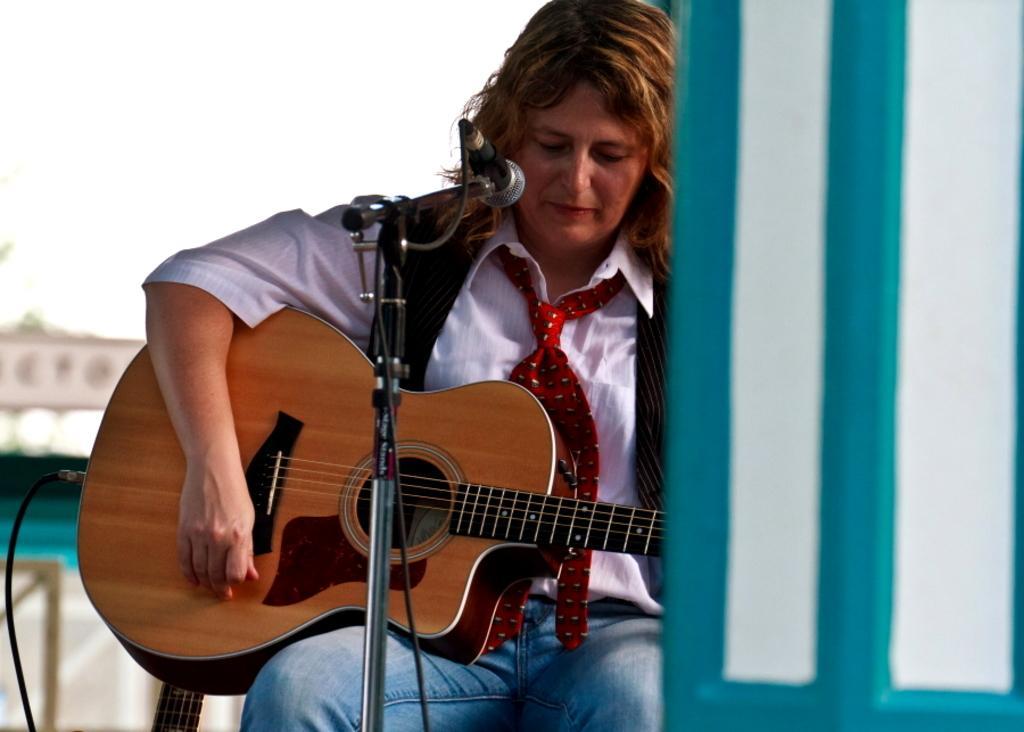Could you give a brief overview of what you see in this image? In this picture we can see a person who is sitting on the chair. She is playing guitar and this is mike. 